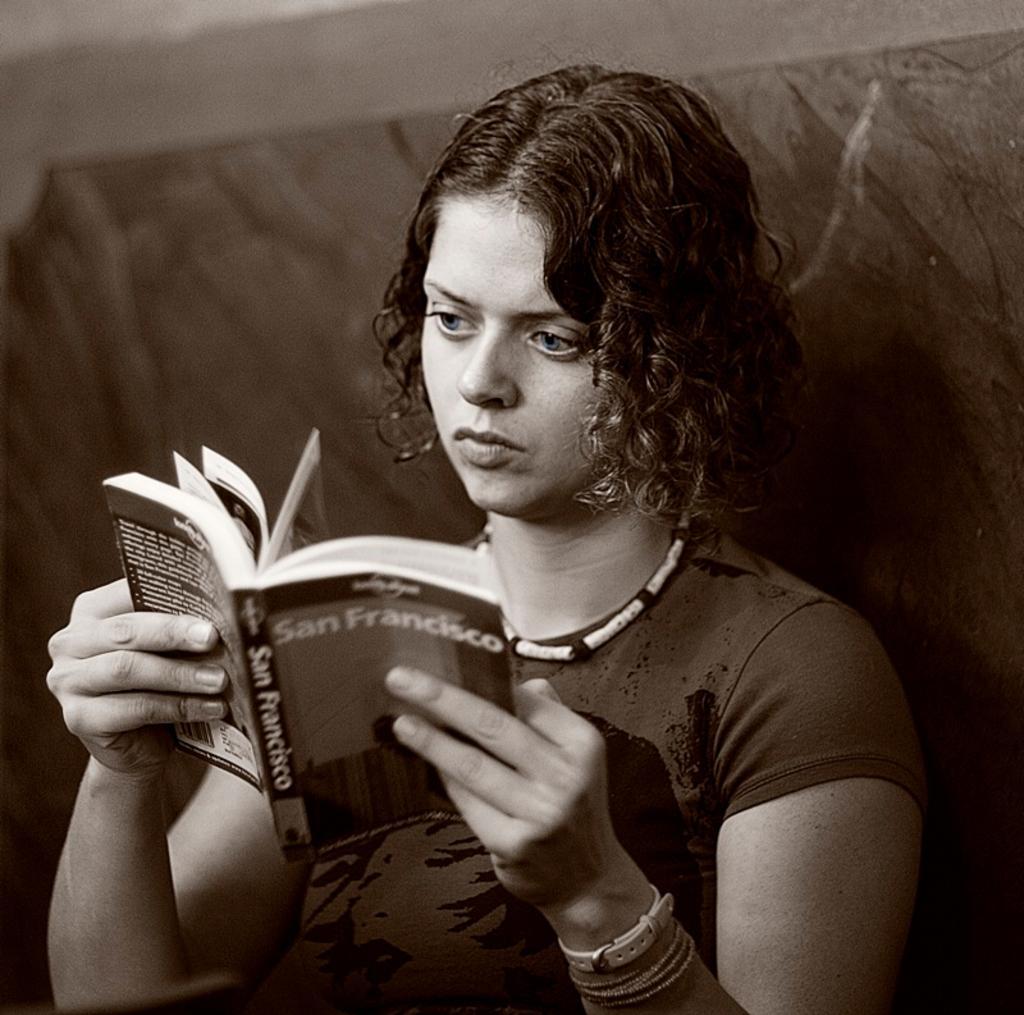Describe this image in one or two sentences. In this image we can see a lady sitting and holding a book. In the background there is a wall. 